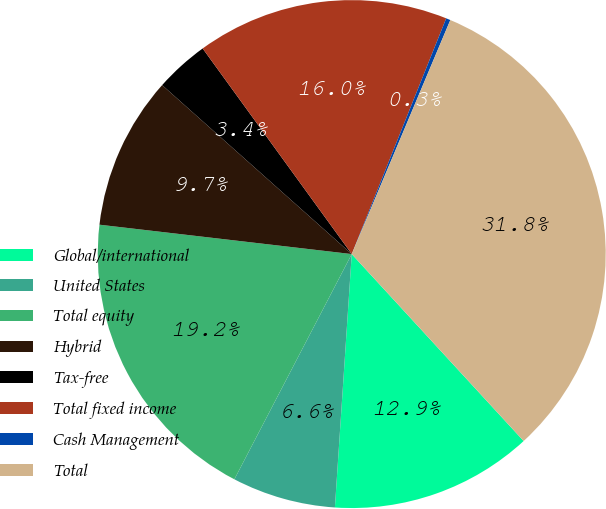Convert chart to OTSL. <chart><loc_0><loc_0><loc_500><loc_500><pie_chart><fcel>Global/international<fcel>United States<fcel>Total equity<fcel>Hybrid<fcel>Tax-free<fcel>Total fixed income<fcel>Cash Management<fcel>Total<nl><fcel>12.89%<fcel>6.59%<fcel>19.2%<fcel>9.74%<fcel>3.43%<fcel>16.05%<fcel>0.28%<fcel>31.82%<nl></chart> 